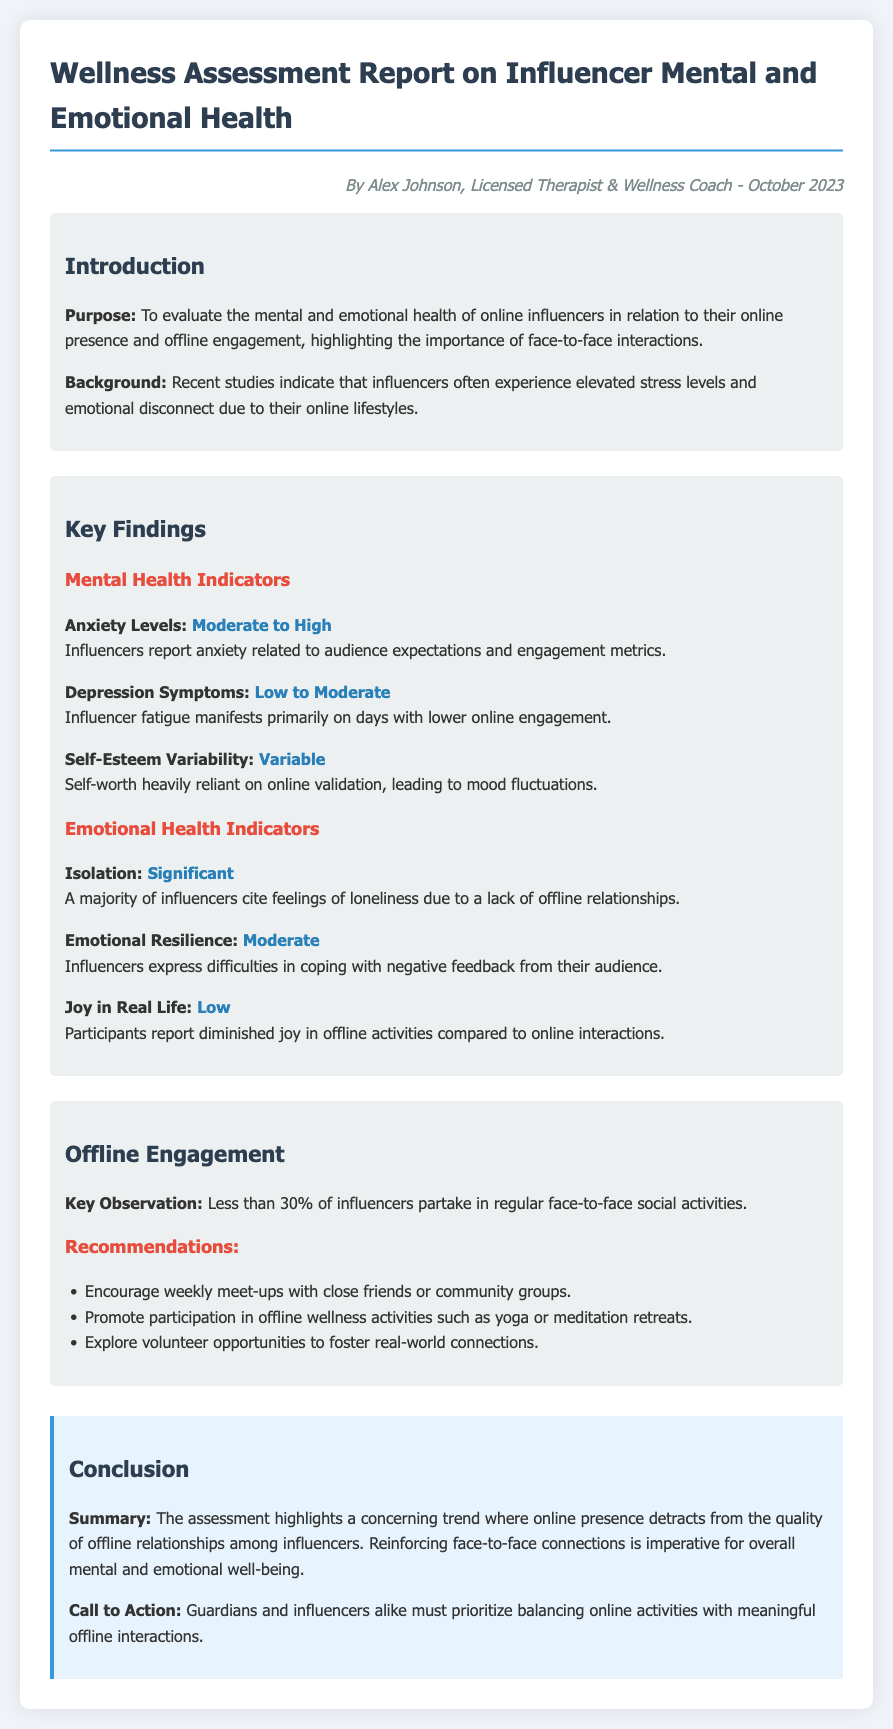What is the title of the document? The title of the document is provided at the top as the main heading.
Answer: Wellness Assessment Report on Influencer Mental and Emotional Health Who is the author of the report? The author's name and title is mentioned in the introduction section.
Answer: Alex Johnson What percentage of influencers participate in offline activities? The percentage is highlighted in the offline engagement section.
Answer: Less than 30% What is the assessment for anxiety levels? The assessment for anxiety levels is included under the mental health indicators.
Answer: Moderate to High What does the report suggest about joy in real life? The assessment of joy in real life is discussed under emotional health indicators.
Answer: Low What recommendation is given for improving offline engagement? Recommendations for offline engagement are listed in the relevant section.
Answer: Encourage weekly meet-ups with close friends or community groups What is the emotional resilience level reported by influencers? The level of emotional resilience is specifically mentioned under emotional health indicators.
Answer: Moderate What is the main call to action mentioned in the conclusion? The call to action is summarized in the conclusion section regarding online and offline balance.
Answer: Prioritize balancing online activities with meaningful offline interactions 